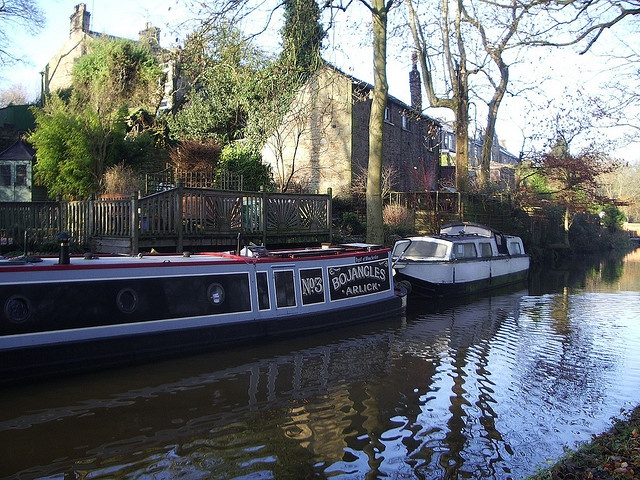Describe the objects in this image and their specific colors. I can see boat in lavender, black, gray, and darkblue tones and boat in lavender, black, and gray tones in this image. 